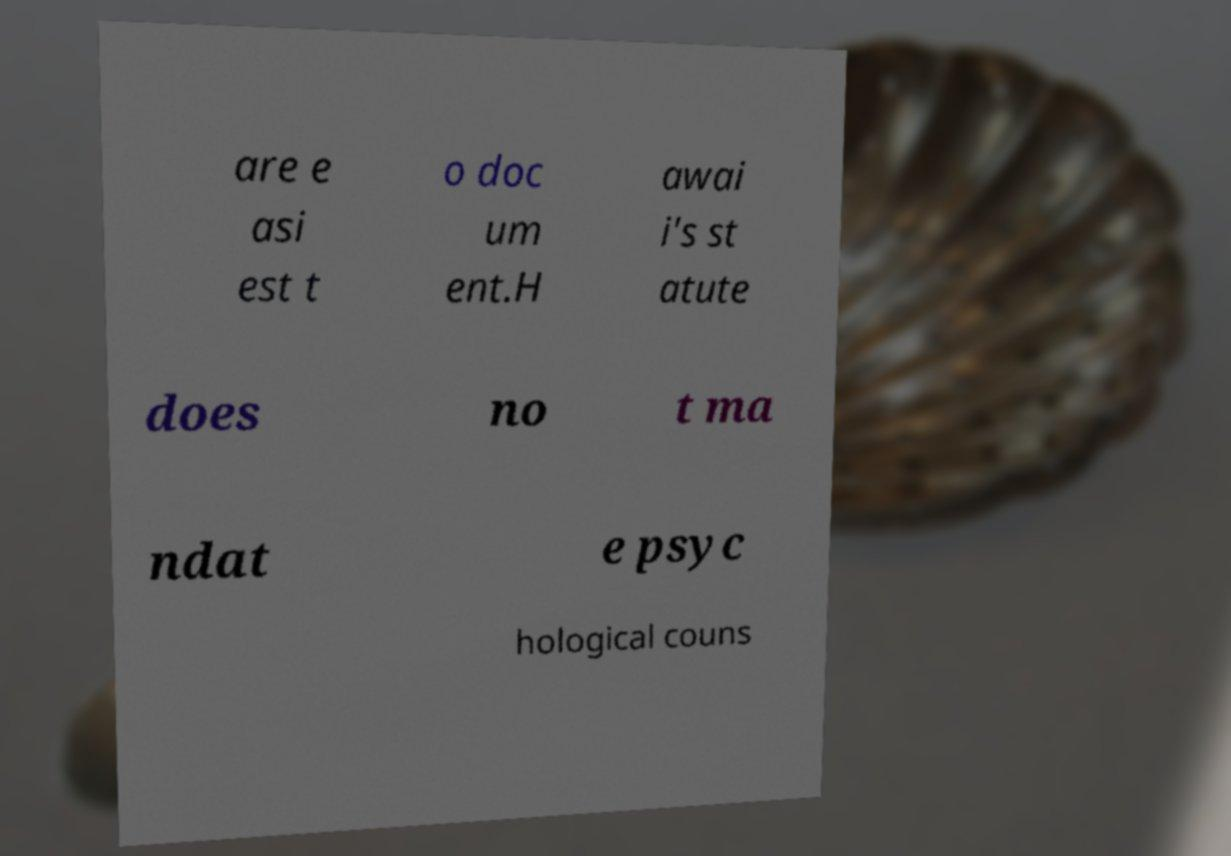I need the written content from this picture converted into text. Can you do that? are e asi est t o doc um ent.H awai i's st atute does no t ma ndat e psyc hological couns 